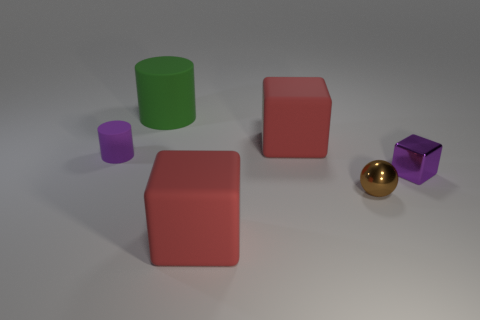Subtract all tiny blocks. How many blocks are left? 2 Subtract 3 cubes. How many cubes are left? 0 Add 1 tiny green rubber things. How many objects exist? 7 Subtract all cyan blocks. How many cyan cylinders are left? 0 Subtract all purple matte cylinders. Subtract all tiny metallic balls. How many objects are left? 4 Add 2 big rubber things. How many big rubber things are left? 5 Add 4 red matte objects. How many red matte objects exist? 6 Subtract all purple cubes. How many cubes are left? 2 Subtract 0 cyan balls. How many objects are left? 6 Subtract all cylinders. How many objects are left? 4 